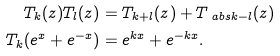Convert formula to latex. <formula><loc_0><loc_0><loc_500><loc_500>T _ { k } ( z ) T _ { l } ( z ) & = T _ { k + l } ( z ) + T _ { \ a b s { k - l } } ( z ) \\ T _ { k } ( e ^ { x } + e ^ { - x } ) & = e ^ { k x } + e ^ { - k x } .</formula> 